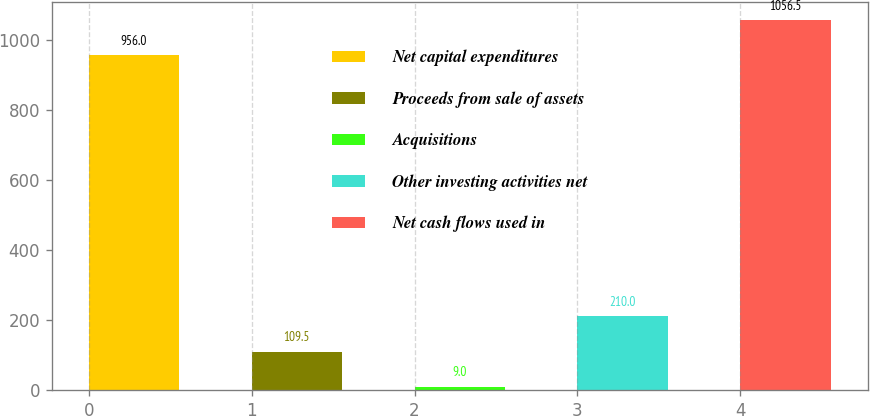Convert chart. <chart><loc_0><loc_0><loc_500><loc_500><bar_chart><fcel>Net capital expenditures<fcel>Proceeds from sale of assets<fcel>Acquisitions<fcel>Other investing activities net<fcel>Net cash flows used in<nl><fcel>956<fcel>109.5<fcel>9<fcel>210<fcel>1056.5<nl></chart> 